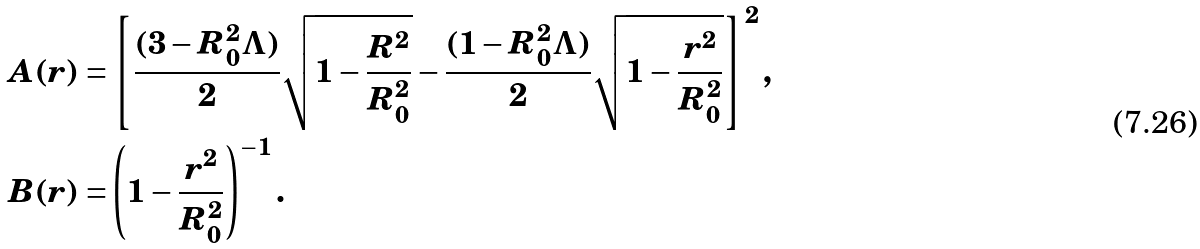Convert formula to latex. <formula><loc_0><loc_0><loc_500><loc_500>A ( r ) = & \left [ \frac { ( 3 - R _ { 0 } ^ { 2 } \Lambda ) } { 2 } \sqrt { 1 - \frac { R ^ { 2 } } { R _ { 0 } ^ { 2 } } } - \frac { ( 1 - R _ { 0 } ^ { 2 } \Lambda ) } { 2 } \sqrt { 1 - \frac { r ^ { 2 } } { R _ { 0 } ^ { 2 } } } \right ] ^ { 2 } , \\ B ( r ) = & \left ( 1 - \frac { r ^ { 2 } } { R _ { 0 } ^ { 2 } } \right ) ^ { - 1 } .</formula> 